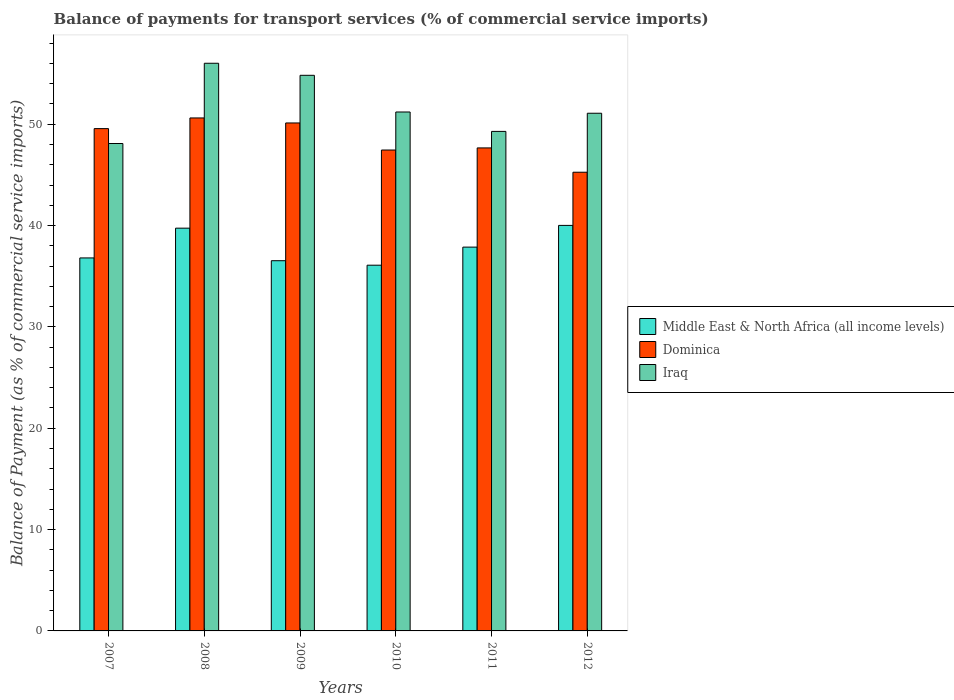How many different coloured bars are there?
Offer a terse response. 3. How many groups of bars are there?
Your response must be concise. 6. Are the number of bars per tick equal to the number of legend labels?
Your response must be concise. Yes. What is the label of the 4th group of bars from the left?
Ensure brevity in your answer.  2010. In how many cases, is the number of bars for a given year not equal to the number of legend labels?
Make the answer very short. 0. What is the balance of payments for transport services in Iraq in 2008?
Keep it short and to the point. 56.02. Across all years, what is the maximum balance of payments for transport services in Middle East & North Africa (all income levels)?
Your answer should be very brief. 40.02. Across all years, what is the minimum balance of payments for transport services in Middle East & North Africa (all income levels)?
Provide a succinct answer. 36.09. In which year was the balance of payments for transport services in Middle East & North Africa (all income levels) maximum?
Keep it short and to the point. 2012. What is the total balance of payments for transport services in Iraq in the graph?
Your response must be concise. 310.52. What is the difference between the balance of payments for transport services in Middle East & North Africa (all income levels) in 2008 and that in 2009?
Your answer should be very brief. 3.21. What is the difference between the balance of payments for transport services in Iraq in 2011 and the balance of payments for transport services in Dominica in 2010?
Make the answer very short. 1.84. What is the average balance of payments for transport services in Iraq per year?
Make the answer very short. 51.75. In the year 2009, what is the difference between the balance of payments for transport services in Middle East & North Africa (all income levels) and balance of payments for transport services in Dominica?
Your response must be concise. -13.59. In how many years, is the balance of payments for transport services in Middle East & North Africa (all income levels) greater than 10 %?
Your answer should be compact. 6. What is the ratio of the balance of payments for transport services in Iraq in 2007 to that in 2010?
Your answer should be compact. 0.94. Is the difference between the balance of payments for transport services in Middle East & North Africa (all income levels) in 2008 and 2011 greater than the difference between the balance of payments for transport services in Dominica in 2008 and 2011?
Your answer should be compact. No. What is the difference between the highest and the second highest balance of payments for transport services in Iraq?
Keep it short and to the point. 1.19. What is the difference between the highest and the lowest balance of payments for transport services in Iraq?
Ensure brevity in your answer.  7.92. In how many years, is the balance of payments for transport services in Middle East & North Africa (all income levels) greater than the average balance of payments for transport services in Middle East & North Africa (all income levels) taken over all years?
Ensure brevity in your answer.  3. Is the sum of the balance of payments for transport services in Iraq in 2008 and 2009 greater than the maximum balance of payments for transport services in Middle East & North Africa (all income levels) across all years?
Provide a succinct answer. Yes. What does the 3rd bar from the left in 2012 represents?
Offer a very short reply. Iraq. What does the 2nd bar from the right in 2007 represents?
Your response must be concise. Dominica. How many bars are there?
Make the answer very short. 18. What is the difference between two consecutive major ticks on the Y-axis?
Provide a succinct answer. 10. Are the values on the major ticks of Y-axis written in scientific E-notation?
Keep it short and to the point. No. Does the graph contain any zero values?
Offer a very short reply. No. How are the legend labels stacked?
Keep it short and to the point. Vertical. What is the title of the graph?
Offer a terse response. Balance of payments for transport services (% of commercial service imports). What is the label or title of the X-axis?
Your answer should be compact. Years. What is the label or title of the Y-axis?
Offer a terse response. Balance of Payment (as % of commercial service imports). What is the Balance of Payment (as % of commercial service imports) of Middle East & North Africa (all income levels) in 2007?
Make the answer very short. 36.81. What is the Balance of Payment (as % of commercial service imports) in Dominica in 2007?
Ensure brevity in your answer.  49.57. What is the Balance of Payment (as % of commercial service imports) of Iraq in 2007?
Offer a very short reply. 48.1. What is the Balance of Payment (as % of commercial service imports) in Middle East & North Africa (all income levels) in 2008?
Give a very brief answer. 39.74. What is the Balance of Payment (as % of commercial service imports) of Dominica in 2008?
Make the answer very short. 50.62. What is the Balance of Payment (as % of commercial service imports) of Iraq in 2008?
Make the answer very short. 56.02. What is the Balance of Payment (as % of commercial service imports) in Middle East & North Africa (all income levels) in 2009?
Your answer should be very brief. 36.53. What is the Balance of Payment (as % of commercial service imports) of Dominica in 2009?
Your answer should be very brief. 50.12. What is the Balance of Payment (as % of commercial service imports) in Iraq in 2009?
Your answer should be compact. 54.83. What is the Balance of Payment (as % of commercial service imports) of Middle East & North Africa (all income levels) in 2010?
Provide a short and direct response. 36.09. What is the Balance of Payment (as % of commercial service imports) of Dominica in 2010?
Offer a terse response. 47.45. What is the Balance of Payment (as % of commercial service imports) in Iraq in 2010?
Offer a terse response. 51.21. What is the Balance of Payment (as % of commercial service imports) in Middle East & North Africa (all income levels) in 2011?
Your response must be concise. 37.87. What is the Balance of Payment (as % of commercial service imports) of Dominica in 2011?
Provide a short and direct response. 47.66. What is the Balance of Payment (as % of commercial service imports) in Iraq in 2011?
Offer a terse response. 49.29. What is the Balance of Payment (as % of commercial service imports) in Middle East & North Africa (all income levels) in 2012?
Your response must be concise. 40.02. What is the Balance of Payment (as % of commercial service imports) of Dominica in 2012?
Provide a succinct answer. 45.26. What is the Balance of Payment (as % of commercial service imports) of Iraq in 2012?
Ensure brevity in your answer.  51.08. Across all years, what is the maximum Balance of Payment (as % of commercial service imports) in Middle East & North Africa (all income levels)?
Provide a succinct answer. 40.02. Across all years, what is the maximum Balance of Payment (as % of commercial service imports) in Dominica?
Keep it short and to the point. 50.62. Across all years, what is the maximum Balance of Payment (as % of commercial service imports) of Iraq?
Ensure brevity in your answer.  56.02. Across all years, what is the minimum Balance of Payment (as % of commercial service imports) of Middle East & North Africa (all income levels)?
Ensure brevity in your answer.  36.09. Across all years, what is the minimum Balance of Payment (as % of commercial service imports) in Dominica?
Your answer should be very brief. 45.26. Across all years, what is the minimum Balance of Payment (as % of commercial service imports) in Iraq?
Offer a terse response. 48.1. What is the total Balance of Payment (as % of commercial service imports) in Middle East & North Africa (all income levels) in the graph?
Give a very brief answer. 227.06. What is the total Balance of Payment (as % of commercial service imports) of Dominica in the graph?
Make the answer very short. 290.69. What is the total Balance of Payment (as % of commercial service imports) in Iraq in the graph?
Offer a very short reply. 310.52. What is the difference between the Balance of Payment (as % of commercial service imports) in Middle East & North Africa (all income levels) in 2007 and that in 2008?
Your answer should be compact. -2.94. What is the difference between the Balance of Payment (as % of commercial service imports) in Dominica in 2007 and that in 2008?
Provide a succinct answer. -1.05. What is the difference between the Balance of Payment (as % of commercial service imports) in Iraq in 2007 and that in 2008?
Offer a very short reply. -7.92. What is the difference between the Balance of Payment (as % of commercial service imports) of Middle East & North Africa (all income levels) in 2007 and that in 2009?
Make the answer very short. 0.27. What is the difference between the Balance of Payment (as % of commercial service imports) of Dominica in 2007 and that in 2009?
Your answer should be compact. -0.56. What is the difference between the Balance of Payment (as % of commercial service imports) of Iraq in 2007 and that in 2009?
Your response must be concise. -6.73. What is the difference between the Balance of Payment (as % of commercial service imports) in Middle East & North Africa (all income levels) in 2007 and that in 2010?
Your answer should be very brief. 0.72. What is the difference between the Balance of Payment (as % of commercial service imports) of Dominica in 2007 and that in 2010?
Your answer should be compact. 2.11. What is the difference between the Balance of Payment (as % of commercial service imports) in Iraq in 2007 and that in 2010?
Give a very brief answer. -3.11. What is the difference between the Balance of Payment (as % of commercial service imports) in Middle East & North Africa (all income levels) in 2007 and that in 2011?
Ensure brevity in your answer.  -1.07. What is the difference between the Balance of Payment (as % of commercial service imports) of Dominica in 2007 and that in 2011?
Ensure brevity in your answer.  1.9. What is the difference between the Balance of Payment (as % of commercial service imports) of Iraq in 2007 and that in 2011?
Provide a short and direct response. -1.2. What is the difference between the Balance of Payment (as % of commercial service imports) of Middle East & North Africa (all income levels) in 2007 and that in 2012?
Provide a short and direct response. -3.21. What is the difference between the Balance of Payment (as % of commercial service imports) of Dominica in 2007 and that in 2012?
Keep it short and to the point. 4.3. What is the difference between the Balance of Payment (as % of commercial service imports) of Iraq in 2007 and that in 2012?
Your answer should be compact. -2.99. What is the difference between the Balance of Payment (as % of commercial service imports) in Middle East & North Africa (all income levels) in 2008 and that in 2009?
Your answer should be very brief. 3.21. What is the difference between the Balance of Payment (as % of commercial service imports) in Dominica in 2008 and that in 2009?
Your answer should be very brief. 0.49. What is the difference between the Balance of Payment (as % of commercial service imports) of Iraq in 2008 and that in 2009?
Provide a succinct answer. 1.19. What is the difference between the Balance of Payment (as % of commercial service imports) of Middle East & North Africa (all income levels) in 2008 and that in 2010?
Provide a succinct answer. 3.65. What is the difference between the Balance of Payment (as % of commercial service imports) of Dominica in 2008 and that in 2010?
Offer a very short reply. 3.16. What is the difference between the Balance of Payment (as % of commercial service imports) of Iraq in 2008 and that in 2010?
Provide a short and direct response. 4.81. What is the difference between the Balance of Payment (as % of commercial service imports) of Middle East & North Africa (all income levels) in 2008 and that in 2011?
Offer a terse response. 1.87. What is the difference between the Balance of Payment (as % of commercial service imports) in Dominica in 2008 and that in 2011?
Ensure brevity in your answer.  2.96. What is the difference between the Balance of Payment (as % of commercial service imports) of Iraq in 2008 and that in 2011?
Give a very brief answer. 6.72. What is the difference between the Balance of Payment (as % of commercial service imports) in Middle East & North Africa (all income levels) in 2008 and that in 2012?
Ensure brevity in your answer.  -0.27. What is the difference between the Balance of Payment (as % of commercial service imports) of Dominica in 2008 and that in 2012?
Provide a short and direct response. 5.36. What is the difference between the Balance of Payment (as % of commercial service imports) of Iraq in 2008 and that in 2012?
Make the answer very short. 4.93. What is the difference between the Balance of Payment (as % of commercial service imports) of Middle East & North Africa (all income levels) in 2009 and that in 2010?
Ensure brevity in your answer.  0.44. What is the difference between the Balance of Payment (as % of commercial service imports) of Dominica in 2009 and that in 2010?
Your answer should be compact. 2.67. What is the difference between the Balance of Payment (as % of commercial service imports) in Iraq in 2009 and that in 2010?
Provide a succinct answer. 3.62. What is the difference between the Balance of Payment (as % of commercial service imports) in Middle East & North Africa (all income levels) in 2009 and that in 2011?
Offer a very short reply. -1.34. What is the difference between the Balance of Payment (as % of commercial service imports) in Dominica in 2009 and that in 2011?
Your answer should be very brief. 2.46. What is the difference between the Balance of Payment (as % of commercial service imports) in Iraq in 2009 and that in 2011?
Your answer should be very brief. 5.54. What is the difference between the Balance of Payment (as % of commercial service imports) of Middle East & North Africa (all income levels) in 2009 and that in 2012?
Make the answer very short. -3.48. What is the difference between the Balance of Payment (as % of commercial service imports) of Dominica in 2009 and that in 2012?
Make the answer very short. 4.86. What is the difference between the Balance of Payment (as % of commercial service imports) of Iraq in 2009 and that in 2012?
Offer a terse response. 3.74. What is the difference between the Balance of Payment (as % of commercial service imports) of Middle East & North Africa (all income levels) in 2010 and that in 2011?
Provide a short and direct response. -1.78. What is the difference between the Balance of Payment (as % of commercial service imports) of Dominica in 2010 and that in 2011?
Provide a short and direct response. -0.21. What is the difference between the Balance of Payment (as % of commercial service imports) in Iraq in 2010 and that in 2011?
Provide a succinct answer. 1.92. What is the difference between the Balance of Payment (as % of commercial service imports) of Middle East & North Africa (all income levels) in 2010 and that in 2012?
Give a very brief answer. -3.93. What is the difference between the Balance of Payment (as % of commercial service imports) in Dominica in 2010 and that in 2012?
Your answer should be compact. 2.19. What is the difference between the Balance of Payment (as % of commercial service imports) in Iraq in 2010 and that in 2012?
Provide a short and direct response. 0.12. What is the difference between the Balance of Payment (as % of commercial service imports) in Middle East & North Africa (all income levels) in 2011 and that in 2012?
Give a very brief answer. -2.14. What is the difference between the Balance of Payment (as % of commercial service imports) in Dominica in 2011 and that in 2012?
Ensure brevity in your answer.  2.4. What is the difference between the Balance of Payment (as % of commercial service imports) in Iraq in 2011 and that in 2012?
Give a very brief answer. -1.79. What is the difference between the Balance of Payment (as % of commercial service imports) of Middle East & North Africa (all income levels) in 2007 and the Balance of Payment (as % of commercial service imports) of Dominica in 2008?
Your response must be concise. -13.81. What is the difference between the Balance of Payment (as % of commercial service imports) in Middle East & North Africa (all income levels) in 2007 and the Balance of Payment (as % of commercial service imports) in Iraq in 2008?
Your response must be concise. -19.21. What is the difference between the Balance of Payment (as % of commercial service imports) of Dominica in 2007 and the Balance of Payment (as % of commercial service imports) of Iraq in 2008?
Offer a terse response. -6.45. What is the difference between the Balance of Payment (as % of commercial service imports) of Middle East & North Africa (all income levels) in 2007 and the Balance of Payment (as % of commercial service imports) of Dominica in 2009?
Give a very brief answer. -13.32. What is the difference between the Balance of Payment (as % of commercial service imports) in Middle East & North Africa (all income levels) in 2007 and the Balance of Payment (as % of commercial service imports) in Iraq in 2009?
Your response must be concise. -18.02. What is the difference between the Balance of Payment (as % of commercial service imports) of Dominica in 2007 and the Balance of Payment (as % of commercial service imports) of Iraq in 2009?
Your answer should be compact. -5.26. What is the difference between the Balance of Payment (as % of commercial service imports) in Middle East & North Africa (all income levels) in 2007 and the Balance of Payment (as % of commercial service imports) in Dominica in 2010?
Offer a terse response. -10.65. What is the difference between the Balance of Payment (as % of commercial service imports) of Middle East & North Africa (all income levels) in 2007 and the Balance of Payment (as % of commercial service imports) of Iraq in 2010?
Keep it short and to the point. -14.4. What is the difference between the Balance of Payment (as % of commercial service imports) in Dominica in 2007 and the Balance of Payment (as % of commercial service imports) in Iraq in 2010?
Offer a very short reply. -1.64. What is the difference between the Balance of Payment (as % of commercial service imports) in Middle East & North Africa (all income levels) in 2007 and the Balance of Payment (as % of commercial service imports) in Dominica in 2011?
Your answer should be very brief. -10.86. What is the difference between the Balance of Payment (as % of commercial service imports) of Middle East & North Africa (all income levels) in 2007 and the Balance of Payment (as % of commercial service imports) of Iraq in 2011?
Your answer should be very brief. -12.49. What is the difference between the Balance of Payment (as % of commercial service imports) of Dominica in 2007 and the Balance of Payment (as % of commercial service imports) of Iraq in 2011?
Your answer should be very brief. 0.27. What is the difference between the Balance of Payment (as % of commercial service imports) of Middle East & North Africa (all income levels) in 2007 and the Balance of Payment (as % of commercial service imports) of Dominica in 2012?
Your response must be concise. -8.46. What is the difference between the Balance of Payment (as % of commercial service imports) of Middle East & North Africa (all income levels) in 2007 and the Balance of Payment (as % of commercial service imports) of Iraq in 2012?
Your answer should be very brief. -14.28. What is the difference between the Balance of Payment (as % of commercial service imports) of Dominica in 2007 and the Balance of Payment (as % of commercial service imports) of Iraq in 2012?
Offer a very short reply. -1.52. What is the difference between the Balance of Payment (as % of commercial service imports) of Middle East & North Africa (all income levels) in 2008 and the Balance of Payment (as % of commercial service imports) of Dominica in 2009?
Give a very brief answer. -10.38. What is the difference between the Balance of Payment (as % of commercial service imports) of Middle East & North Africa (all income levels) in 2008 and the Balance of Payment (as % of commercial service imports) of Iraq in 2009?
Give a very brief answer. -15.08. What is the difference between the Balance of Payment (as % of commercial service imports) of Dominica in 2008 and the Balance of Payment (as % of commercial service imports) of Iraq in 2009?
Make the answer very short. -4.21. What is the difference between the Balance of Payment (as % of commercial service imports) in Middle East & North Africa (all income levels) in 2008 and the Balance of Payment (as % of commercial service imports) in Dominica in 2010?
Provide a succinct answer. -7.71. What is the difference between the Balance of Payment (as % of commercial service imports) in Middle East & North Africa (all income levels) in 2008 and the Balance of Payment (as % of commercial service imports) in Iraq in 2010?
Ensure brevity in your answer.  -11.46. What is the difference between the Balance of Payment (as % of commercial service imports) in Dominica in 2008 and the Balance of Payment (as % of commercial service imports) in Iraq in 2010?
Offer a terse response. -0.59. What is the difference between the Balance of Payment (as % of commercial service imports) of Middle East & North Africa (all income levels) in 2008 and the Balance of Payment (as % of commercial service imports) of Dominica in 2011?
Your answer should be very brief. -7.92. What is the difference between the Balance of Payment (as % of commercial service imports) in Middle East & North Africa (all income levels) in 2008 and the Balance of Payment (as % of commercial service imports) in Iraq in 2011?
Make the answer very short. -9.55. What is the difference between the Balance of Payment (as % of commercial service imports) in Dominica in 2008 and the Balance of Payment (as % of commercial service imports) in Iraq in 2011?
Give a very brief answer. 1.33. What is the difference between the Balance of Payment (as % of commercial service imports) of Middle East & North Africa (all income levels) in 2008 and the Balance of Payment (as % of commercial service imports) of Dominica in 2012?
Keep it short and to the point. -5.52. What is the difference between the Balance of Payment (as % of commercial service imports) in Middle East & North Africa (all income levels) in 2008 and the Balance of Payment (as % of commercial service imports) in Iraq in 2012?
Keep it short and to the point. -11.34. What is the difference between the Balance of Payment (as % of commercial service imports) in Dominica in 2008 and the Balance of Payment (as % of commercial service imports) in Iraq in 2012?
Your answer should be very brief. -0.46. What is the difference between the Balance of Payment (as % of commercial service imports) in Middle East & North Africa (all income levels) in 2009 and the Balance of Payment (as % of commercial service imports) in Dominica in 2010?
Your answer should be compact. -10.92. What is the difference between the Balance of Payment (as % of commercial service imports) in Middle East & North Africa (all income levels) in 2009 and the Balance of Payment (as % of commercial service imports) in Iraq in 2010?
Offer a terse response. -14.68. What is the difference between the Balance of Payment (as % of commercial service imports) of Dominica in 2009 and the Balance of Payment (as % of commercial service imports) of Iraq in 2010?
Your answer should be compact. -1.08. What is the difference between the Balance of Payment (as % of commercial service imports) in Middle East & North Africa (all income levels) in 2009 and the Balance of Payment (as % of commercial service imports) in Dominica in 2011?
Provide a succinct answer. -11.13. What is the difference between the Balance of Payment (as % of commercial service imports) in Middle East & North Africa (all income levels) in 2009 and the Balance of Payment (as % of commercial service imports) in Iraq in 2011?
Ensure brevity in your answer.  -12.76. What is the difference between the Balance of Payment (as % of commercial service imports) in Dominica in 2009 and the Balance of Payment (as % of commercial service imports) in Iraq in 2011?
Offer a very short reply. 0.83. What is the difference between the Balance of Payment (as % of commercial service imports) of Middle East & North Africa (all income levels) in 2009 and the Balance of Payment (as % of commercial service imports) of Dominica in 2012?
Give a very brief answer. -8.73. What is the difference between the Balance of Payment (as % of commercial service imports) of Middle East & North Africa (all income levels) in 2009 and the Balance of Payment (as % of commercial service imports) of Iraq in 2012?
Your answer should be very brief. -14.55. What is the difference between the Balance of Payment (as % of commercial service imports) in Dominica in 2009 and the Balance of Payment (as % of commercial service imports) in Iraq in 2012?
Your answer should be compact. -0.96. What is the difference between the Balance of Payment (as % of commercial service imports) of Middle East & North Africa (all income levels) in 2010 and the Balance of Payment (as % of commercial service imports) of Dominica in 2011?
Give a very brief answer. -11.57. What is the difference between the Balance of Payment (as % of commercial service imports) of Middle East & North Africa (all income levels) in 2010 and the Balance of Payment (as % of commercial service imports) of Iraq in 2011?
Ensure brevity in your answer.  -13.2. What is the difference between the Balance of Payment (as % of commercial service imports) in Dominica in 2010 and the Balance of Payment (as % of commercial service imports) in Iraq in 2011?
Your answer should be very brief. -1.84. What is the difference between the Balance of Payment (as % of commercial service imports) in Middle East & North Africa (all income levels) in 2010 and the Balance of Payment (as % of commercial service imports) in Dominica in 2012?
Provide a succinct answer. -9.17. What is the difference between the Balance of Payment (as % of commercial service imports) of Middle East & North Africa (all income levels) in 2010 and the Balance of Payment (as % of commercial service imports) of Iraq in 2012?
Provide a succinct answer. -14.99. What is the difference between the Balance of Payment (as % of commercial service imports) in Dominica in 2010 and the Balance of Payment (as % of commercial service imports) in Iraq in 2012?
Provide a succinct answer. -3.63. What is the difference between the Balance of Payment (as % of commercial service imports) in Middle East & North Africa (all income levels) in 2011 and the Balance of Payment (as % of commercial service imports) in Dominica in 2012?
Your answer should be very brief. -7.39. What is the difference between the Balance of Payment (as % of commercial service imports) of Middle East & North Africa (all income levels) in 2011 and the Balance of Payment (as % of commercial service imports) of Iraq in 2012?
Offer a terse response. -13.21. What is the difference between the Balance of Payment (as % of commercial service imports) of Dominica in 2011 and the Balance of Payment (as % of commercial service imports) of Iraq in 2012?
Give a very brief answer. -3.42. What is the average Balance of Payment (as % of commercial service imports) in Middle East & North Africa (all income levels) per year?
Ensure brevity in your answer.  37.84. What is the average Balance of Payment (as % of commercial service imports) in Dominica per year?
Make the answer very short. 48.45. What is the average Balance of Payment (as % of commercial service imports) of Iraq per year?
Your answer should be compact. 51.75. In the year 2007, what is the difference between the Balance of Payment (as % of commercial service imports) of Middle East & North Africa (all income levels) and Balance of Payment (as % of commercial service imports) of Dominica?
Provide a succinct answer. -12.76. In the year 2007, what is the difference between the Balance of Payment (as % of commercial service imports) of Middle East & North Africa (all income levels) and Balance of Payment (as % of commercial service imports) of Iraq?
Give a very brief answer. -11.29. In the year 2007, what is the difference between the Balance of Payment (as % of commercial service imports) of Dominica and Balance of Payment (as % of commercial service imports) of Iraq?
Provide a short and direct response. 1.47. In the year 2008, what is the difference between the Balance of Payment (as % of commercial service imports) of Middle East & North Africa (all income levels) and Balance of Payment (as % of commercial service imports) of Dominica?
Give a very brief answer. -10.87. In the year 2008, what is the difference between the Balance of Payment (as % of commercial service imports) of Middle East & North Africa (all income levels) and Balance of Payment (as % of commercial service imports) of Iraq?
Offer a very short reply. -16.27. In the year 2008, what is the difference between the Balance of Payment (as % of commercial service imports) in Dominica and Balance of Payment (as % of commercial service imports) in Iraq?
Ensure brevity in your answer.  -5.4. In the year 2009, what is the difference between the Balance of Payment (as % of commercial service imports) of Middle East & North Africa (all income levels) and Balance of Payment (as % of commercial service imports) of Dominica?
Give a very brief answer. -13.59. In the year 2009, what is the difference between the Balance of Payment (as % of commercial service imports) in Middle East & North Africa (all income levels) and Balance of Payment (as % of commercial service imports) in Iraq?
Offer a very short reply. -18.3. In the year 2009, what is the difference between the Balance of Payment (as % of commercial service imports) of Dominica and Balance of Payment (as % of commercial service imports) of Iraq?
Make the answer very short. -4.7. In the year 2010, what is the difference between the Balance of Payment (as % of commercial service imports) in Middle East & North Africa (all income levels) and Balance of Payment (as % of commercial service imports) in Dominica?
Make the answer very short. -11.37. In the year 2010, what is the difference between the Balance of Payment (as % of commercial service imports) of Middle East & North Africa (all income levels) and Balance of Payment (as % of commercial service imports) of Iraq?
Provide a succinct answer. -15.12. In the year 2010, what is the difference between the Balance of Payment (as % of commercial service imports) in Dominica and Balance of Payment (as % of commercial service imports) in Iraq?
Your answer should be compact. -3.75. In the year 2011, what is the difference between the Balance of Payment (as % of commercial service imports) in Middle East & North Africa (all income levels) and Balance of Payment (as % of commercial service imports) in Dominica?
Make the answer very short. -9.79. In the year 2011, what is the difference between the Balance of Payment (as % of commercial service imports) in Middle East & North Africa (all income levels) and Balance of Payment (as % of commercial service imports) in Iraq?
Keep it short and to the point. -11.42. In the year 2011, what is the difference between the Balance of Payment (as % of commercial service imports) of Dominica and Balance of Payment (as % of commercial service imports) of Iraq?
Your answer should be very brief. -1.63. In the year 2012, what is the difference between the Balance of Payment (as % of commercial service imports) of Middle East & North Africa (all income levels) and Balance of Payment (as % of commercial service imports) of Dominica?
Ensure brevity in your answer.  -5.25. In the year 2012, what is the difference between the Balance of Payment (as % of commercial service imports) of Middle East & North Africa (all income levels) and Balance of Payment (as % of commercial service imports) of Iraq?
Keep it short and to the point. -11.07. In the year 2012, what is the difference between the Balance of Payment (as % of commercial service imports) of Dominica and Balance of Payment (as % of commercial service imports) of Iraq?
Your response must be concise. -5.82. What is the ratio of the Balance of Payment (as % of commercial service imports) of Middle East & North Africa (all income levels) in 2007 to that in 2008?
Your answer should be compact. 0.93. What is the ratio of the Balance of Payment (as % of commercial service imports) in Dominica in 2007 to that in 2008?
Provide a succinct answer. 0.98. What is the ratio of the Balance of Payment (as % of commercial service imports) in Iraq in 2007 to that in 2008?
Ensure brevity in your answer.  0.86. What is the ratio of the Balance of Payment (as % of commercial service imports) in Middle East & North Africa (all income levels) in 2007 to that in 2009?
Give a very brief answer. 1.01. What is the ratio of the Balance of Payment (as % of commercial service imports) of Dominica in 2007 to that in 2009?
Your answer should be very brief. 0.99. What is the ratio of the Balance of Payment (as % of commercial service imports) in Iraq in 2007 to that in 2009?
Offer a very short reply. 0.88. What is the ratio of the Balance of Payment (as % of commercial service imports) of Middle East & North Africa (all income levels) in 2007 to that in 2010?
Your response must be concise. 1.02. What is the ratio of the Balance of Payment (as % of commercial service imports) in Dominica in 2007 to that in 2010?
Your answer should be very brief. 1.04. What is the ratio of the Balance of Payment (as % of commercial service imports) of Iraq in 2007 to that in 2010?
Your answer should be compact. 0.94. What is the ratio of the Balance of Payment (as % of commercial service imports) in Middle East & North Africa (all income levels) in 2007 to that in 2011?
Keep it short and to the point. 0.97. What is the ratio of the Balance of Payment (as % of commercial service imports) in Dominica in 2007 to that in 2011?
Offer a terse response. 1.04. What is the ratio of the Balance of Payment (as % of commercial service imports) in Iraq in 2007 to that in 2011?
Provide a succinct answer. 0.98. What is the ratio of the Balance of Payment (as % of commercial service imports) of Middle East & North Africa (all income levels) in 2007 to that in 2012?
Provide a succinct answer. 0.92. What is the ratio of the Balance of Payment (as % of commercial service imports) in Dominica in 2007 to that in 2012?
Ensure brevity in your answer.  1.09. What is the ratio of the Balance of Payment (as % of commercial service imports) of Iraq in 2007 to that in 2012?
Your answer should be compact. 0.94. What is the ratio of the Balance of Payment (as % of commercial service imports) in Middle East & North Africa (all income levels) in 2008 to that in 2009?
Give a very brief answer. 1.09. What is the ratio of the Balance of Payment (as % of commercial service imports) in Dominica in 2008 to that in 2009?
Offer a terse response. 1.01. What is the ratio of the Balance of Payment (as % of commercial service imports) in Iraq in 2008 to that in 2009?
Give a very brief answer. 1.02. What is the ratio of the Balance of Payment (as % of commercial service imports) of Middle East & North Africa (all income levels) in 2008 to that in 2010?
Provide a short and direct response. 1.1. What is the ratio of the Balance of Payment (as % of commercial service imports) of Dominica in 2008 to that in 2010?
Keep it short and to the point. 1.07. What is the ratio of the Balance of Payment (as % of commercial service imports) in Iraq in 2008 to that in 2010?
Give a very brief answer. 1.09. What is the ratio of the Balance of Payment (as % of commercial service imports) in Middle East & North Africa (all income levels) in 2008 to that in 2011?
Ensure brevity in your answer.  1.05. What is the ratio of the Balance of Payment (as % of commercial service imports) in Dominica in 2008 to that in 2011?
Keep it short and to the point. 1.06. What is the ratio of the Balance of Payment (as % of commercial service imports) of Iraq in 2008 to that in 2011?
Offer a very short reply. 1.14. What is the ratio of the Balance of Payment (as % of commercial service imports) in Middle East & North Africa (all income levels) in 2008 to that in 2012?
Your answer should be very brief. 0.99. What is the ratio of the Balance of Payment (as % of commercial service imports) of Dominica in 2008 to that in 2012?
Ensure brevity in your answer.  1.12. What is the ratio of the Balance of Payment (as % of commercial service imports) in Iraq in 2008 to that in 2012?
Your response must be concise. 1.1. What is the ratio of the Balance of Payment (as % of commercial service imports) of Middle East & North Africa (all income levels) in 2009 to that in 2010?
Your answer should be very brief. 1.01. What is the ratio of the Balance of Payment (as % of commercial service imports) in Dominica in 2009 to that in 2010?
Your answer should be very brief. 1.06. What is the ratio of the Balance of Payment (as % of commercial service imports) in Iraq in 2009 to that in 2010?
Your answer should be compact. 1.07. What is the ratio of the Balance of Payment (as % of commercial service imports) in Middle East & North Africa (all income levels) in 2009 to that in 2011?
Your answer should be very brief. 0.96. What is the ratio of the Balance of Payment (as % of commercial service imports) in Dominica in 2009 to that in 2011?
Ensure brevity in your answer.  1.05. What is the ratio of the Balance of Payment (as % of commercial service imports) of Iraq in 2009 to that in 2011?
Your response must be concise. 1.11. What is the ratio of the Balance of Payment (as % of commercial service imports) in Middle East & North Africa (all income levels) in 2009 to that in 2012?
Give a very brief answer. 0.91. What is the ratio of the Balance of Payment (as % of commercial service imports) of Dominica in 2009 to that in 2012?
Provide a succinct answer. 1.11. What is the ratio of the Balance of Payment (as % of commercial service imports) of Iraq in 2009 to that in 2012?
Provide a succinct answer. 1.07. What is the ratio of the Balance of Payment (as % of commercial service imports) in Middle East & North Africa (all income levels) in 2010 to that in 2011?
Offer a very short reply. 0.95. What is the ratio of the Balance of Payment (as % of commercial service imports) of Dominica in 2010 to that in 2011?
Give a very brief answer. 1. What is the ratio of the Balance of Payment (as % of commercial service imports) of Iraq in 2010 to that in 2011?
Your answer should be compact. 1.04. What is the ratio of the Balance of Payment (as % of commercial service imports) of Middle East & North Africa (all income levels) in 2010 to that in 2012?
Offer a very short reply. 0.9. What is the ratio of the Balance of Payment (as % of commercial service imports) in Dominica in 2010 to that in 2012?
Your response must be concise. 1.05. What is the ratio of the Balance of Payment (as % of commercial service imports) in Iraq in 2010 to that in 2012?
Your response must be concise. 1. What is the ratio of the Balance of Payment (as % of commercial service imports) of Middle East & North Africa (all income levels) in 2011 to that in 2012?
Your answer should be compact. 0.95. What is the ratio of the Balance of Payment (as % of commercial service imports) in Dominica in 2011 to that in 2012?
Make the answer very short. 1.05. What is the ratio of the Balance of Payment (as % of commercial service imports) in Iraq in 2011 to that in 2012?
Make the answer very short. 0.96. What is the difference between the highest and the second highest Balance of Payment (as % of commercial service imports) in Middle East & North Africa (all income levels)?
Provide a short and direct response. 0.27. What is the difference between the highest and the second highest Balance of Payment (as % of commercial service imports) in Dominica?
Provide a short and direct response. 0.49. What is the difference between the highest and the second highest Balance of Payment (as % of commercial service imports) of Iraq?
Your response must be concise. 1.19. What is the difference between the highest and the lowest Balance of Payment (as % of commercial service imports) in Middle East & North Africa (all income levels)?
Give a very brief answer. 3.93. What is the difference between the highest and the lowest Balance of Payment (as % of commercial service imports) in Dominica?
Offer a very short reply. 5.36. What is the difference between the highest and the lowest Balance of Payment (as % of commercial service imports) of Iraq?
Your answer should be very brief. 7.92. 